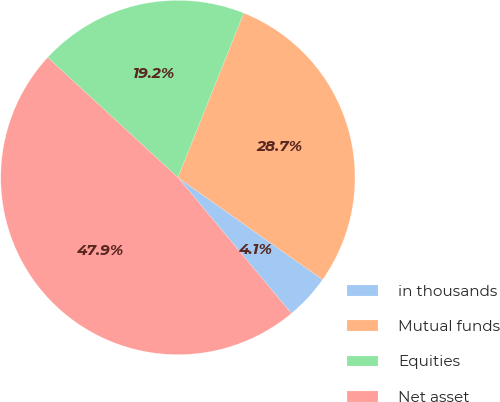Convert chart. <chart><loc_0><loc_0><loc_500><loc_500><pie_chart><fcel>in thousands<fcel>Mutual funds<fcel>Equities<fcel>Net asset<nl><fcel>4.14%<fcel>28.72%<fcel>19.21%<fcel>47.93%<nl></chart> 